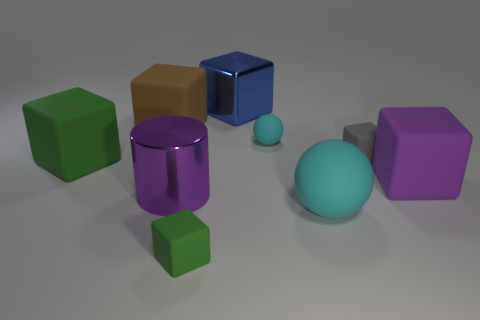Outside of shape, are there any other similarities between the objects? Yes, beyond their shapes, several objects share similar hues and saturation, suggesting the objects could belong to a coordinated set. Additionally, the smooth surfaces and uniform colors of the objects present a visually cohesive group. 